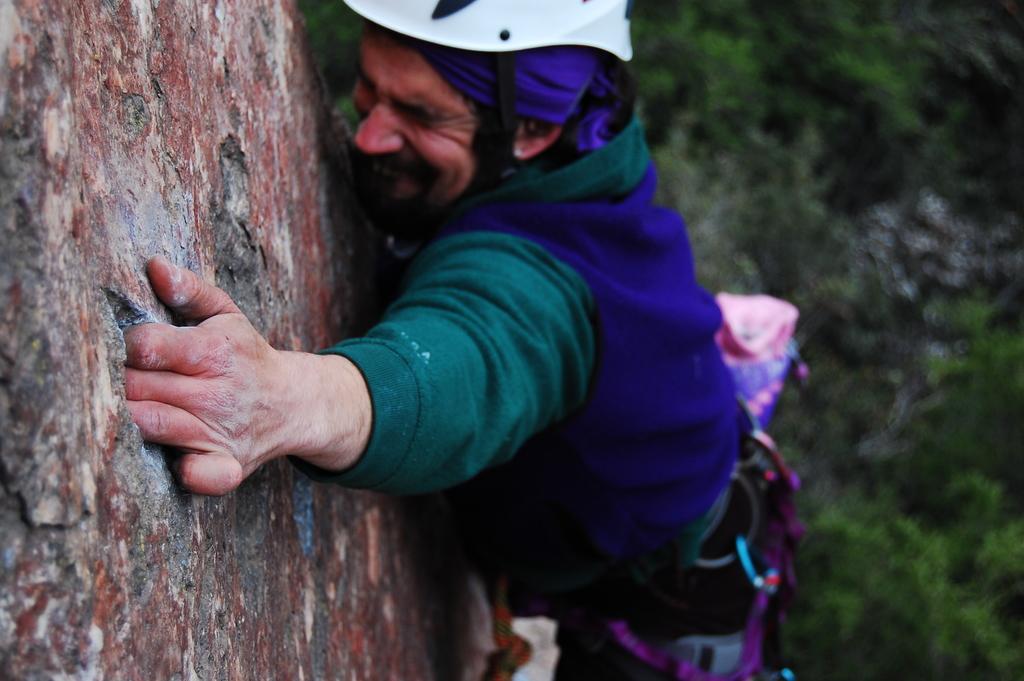Could you give a brief overview of what you see in this image? In this image I can see a person visible in front of the hill and person is doing hill climbing, on the left side, on the right side I can see some trees. 